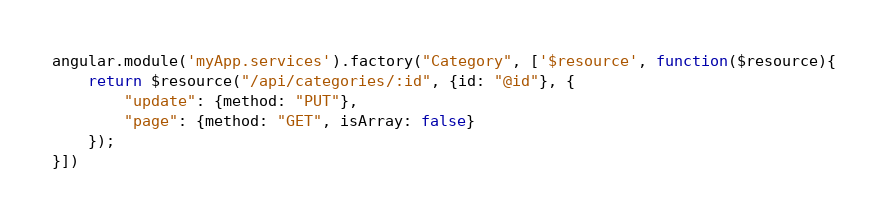<code> <loc_0><loc_0><loc_500><loc_500><_JavaScript_>angular.module('myApp.services').factory("Category", ['$resource', function($resource){
	return $resource("/api/categories/:id", {id: "@id"}, {
        "update": {method: "PUT"},
        "page": {method: "GET", isArray: false}
	});
}])</code> 